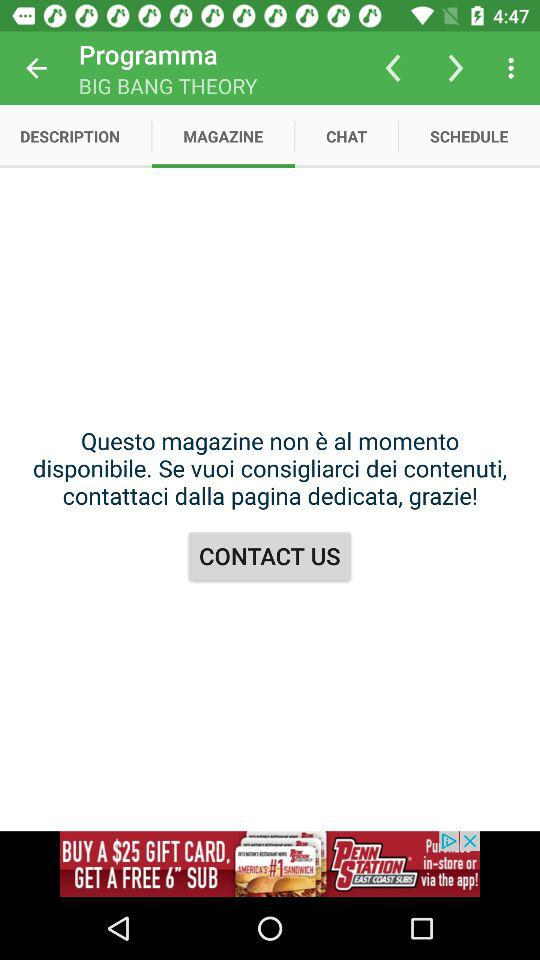Which tab is selected? The selected tab is "MAGAZINE". 